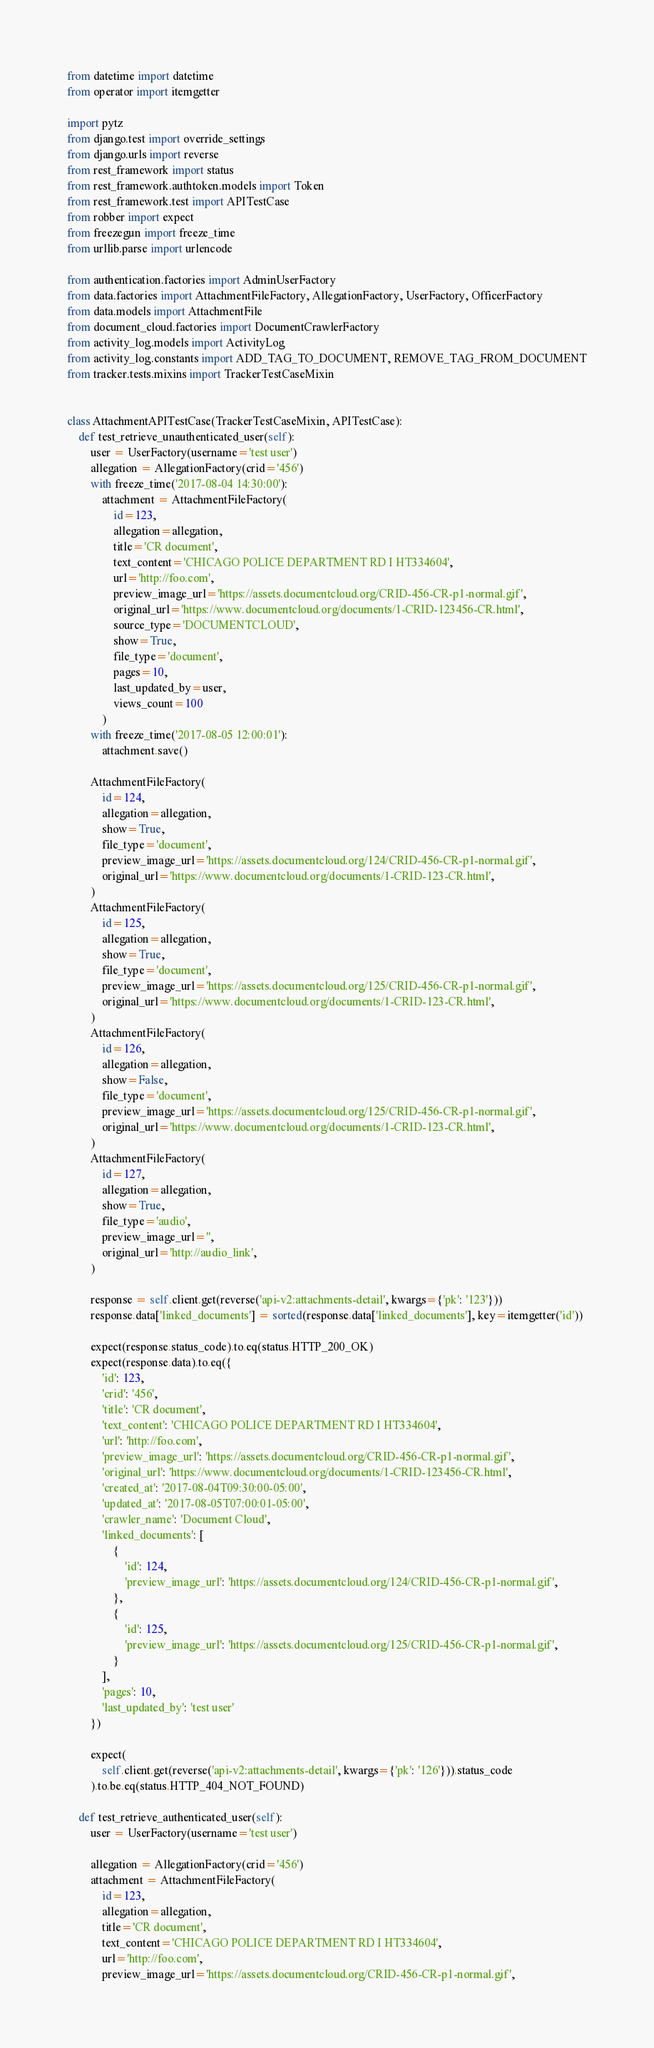<code> <loc_0><loc_0><loc_500><loc_500><_Python_>from datetime import datetime
from operator import itemgetter

import pytz
from django.test import override_settings
from django.urls import reverse
from rest_framework import status
from rest_framework.authtoken.models import Token
from rest_framework.test import APITestCase
from robber import expect
from freezegun import freeze_time
from urllib.parse import urlencode

from authentication.factories import AdminUserFactory
from data.factories import AttachmentFileFactory, AllegationFactory, UserFactory, OfficerFactory
from data.models import AttachmentFile
from document_cloud.factories import DocumentCrawlerFactory
from activity_log.models import ActivityLog
from activity_log.constants import ADD_TAG_TO_DOCUMENT, REMOVE_TAG_FROM_DOCUMENT
from tracker.tests.mixins import TrackerTestCaseMixin


class AttachmentAPITestCase(TrackerTestCaseMixin, APITestCase):
    def test_retrieve_unauthenticated_user(self):
        user = UserFactory(username='test user')
        allegation = AllegationFactory(crid='456')
        with freeze_time('2017-08-04 14:30:00'):
            attachment = AttachmentFileFactory(
                id=123,
                allegation=allegation,
                title='CR document',
                text_content='CHICAGO POLICE DEPARTMENT RD I HT334604',
                url='http://foo.com',
                preview_image_url='https://assets.documentcloud.org/CRID-456-CR-p1-normal.gif',
                original_url='https://www.documentcloud.org/documents/1-CRID-123456-CR.html',
                source_type='DOCUMENTCLOUD',
                show=True,
                file_type='document',
                pages=10,
                last_updated_by=user,
                views_count=100
            )
        with freeze_time('2017-08-05 12:00:01'):
            attachment.save()

        AttachmentFileFactory(
            id=124,
            allegation=allegation,
            show=True,
            file_type='document',
            preview_image_url='https://assets.documentcloud.org/124/CRID-456-CR-p1-normal.gif',
            original_url='https://www.documentcloud.org/documents/1-CRID-123-CR.html',
        )
        AttachmentFileFactory(
            id=125,
            allegation=allegation,
            show=True,
            file_type='document',
            preview_image_url='https://assets.documentcloud.org/125/CRID-456-CR-p1-normal.gif',
            original_url='https://www.documentcloud.org/documents/1-CRID-123-CR.html',
        )
        AttachmentFileFactory(
            id=126,
            allegation=allegation,
            show=False,
            file_type='document',
            preview_image_url='https://assets.documentcloud.org/125/CRID-456-CR-p1-normal.gif',
            original_url='https://www.documentcloud.org/documents/1-CRID-123-CR.html',
        )
        AttachmentFileFactory(
            id=127,
            allegation=allegation,
            show=True,
            file_type='audio',
            preview_image_url='',
            original_url='http://audio_link',
        )

        response = self.client.get(reverse('api-v2:attachments-detail', kwargs={'pk': '123'}))
        response.data['linked_documents'] = sorted(response.data['linked_documents'], key=itemgetter('id'))

        expect(response.status_code).to.eq(status.HTTP_200_OK)
        expect(response.data).to.eq({
            'id': 123,
            'crid': '456',
            'title': 'CR document',
            'text_content': 'CHICAGO POLICE DEPARTMENT RD I HT334604',
            'url': 'http://foo.com',
            'preview_image_url': 'https://assets.documentcloud.org/CRID-456-CR-p1-normal.gif',
            'original_url': 'https://www.documentcloud.org/documents/1-CRID-123456-CR.html',
            'created_at': '2017-08-04T09:30:00-05:00',
            'updated_at': '2017-08-05T07:00:01-05:00',
            'crawler_name': 'Document Cloud',
            'linked_documents': [
                {
                    'id': 124,
                    'preview_image_url': 'https://assets.documentcloud.org/124/CRID-456-CR-p1-normal.gif',
                },
                {
                    'id': 125,
                    'preview_image_url': 'https://assets.documentcloud.org/125/CRID-456-CR-p1-normal.gif',
                }
            ],
            'pages': 10,
            'last_updated_by': 'test user'
        })

        expect(
            self.client.get(reverse('api-v2:attachments-detail', kwargs={'pk': '126'})).status_code
        ).to.be.eq(status.HTTP_404_NOT_FOUND)

    def test_retrieve_authenticated_user(self):
        user = UserFactory(username='test user')

        allegation = AllegationFactory(crid='456')
        attachment = AttachmentFileFactory(
            id=123,
            allegation=allegation,
            title='CR document',
            text_content='CHICAGO POLICE DEPARTMENT RD I HT334604',
            url='http://foo.com',
            preview_image_url='https://assets.documentcloud.org/CRID-456-CR-p1-normal.gif',</code> 